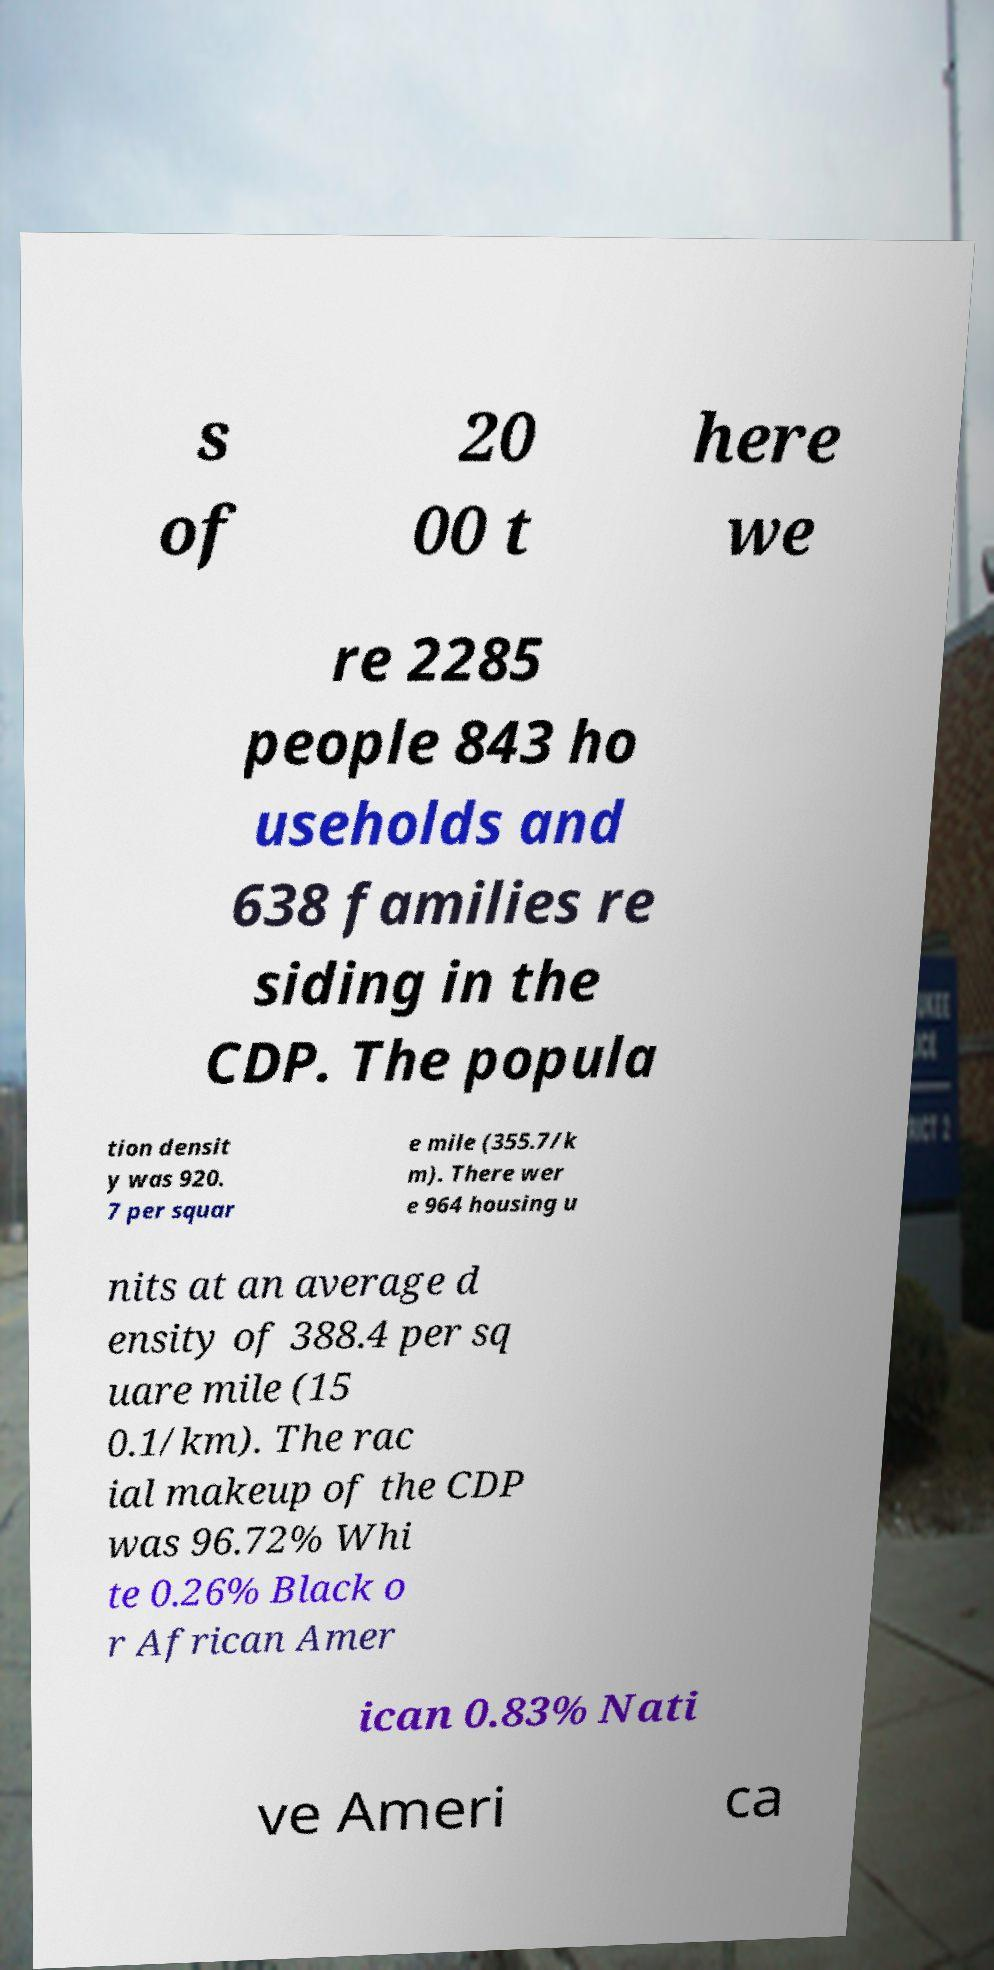Could you assist in decoding the text presented in this image and type it out clearly? s of 20 00 t here we re 2285 people 843 ho useholds and 638 families re siding in the CDP. The popula tion densit y was 920. 7 per squar e mile (355.7/k m). There wer e 964 housing u nits at an average d ensity of 388.4 per sq uare mile (15 0.1/km). The rac ial makeup of the CDP was 96.72% Whi te 0.26% Black o r African Amer ican 0.83% Nati ve Ameri ca 